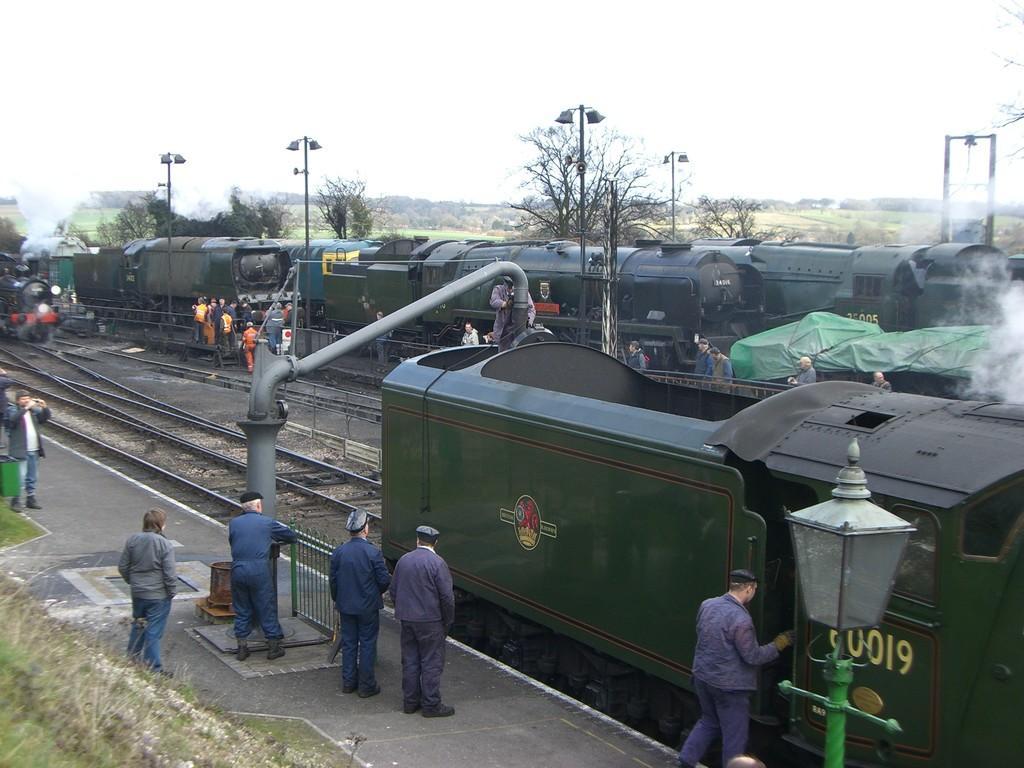Please provide a concise description of this image. In this image, we can see three trains. Here there are few train tracks. At the bottom, there is platform. Few people are standing. Here there is a barricade and grass, some container here. Background we can see so many poles, trees, smoke. Here we can see few people are there. 